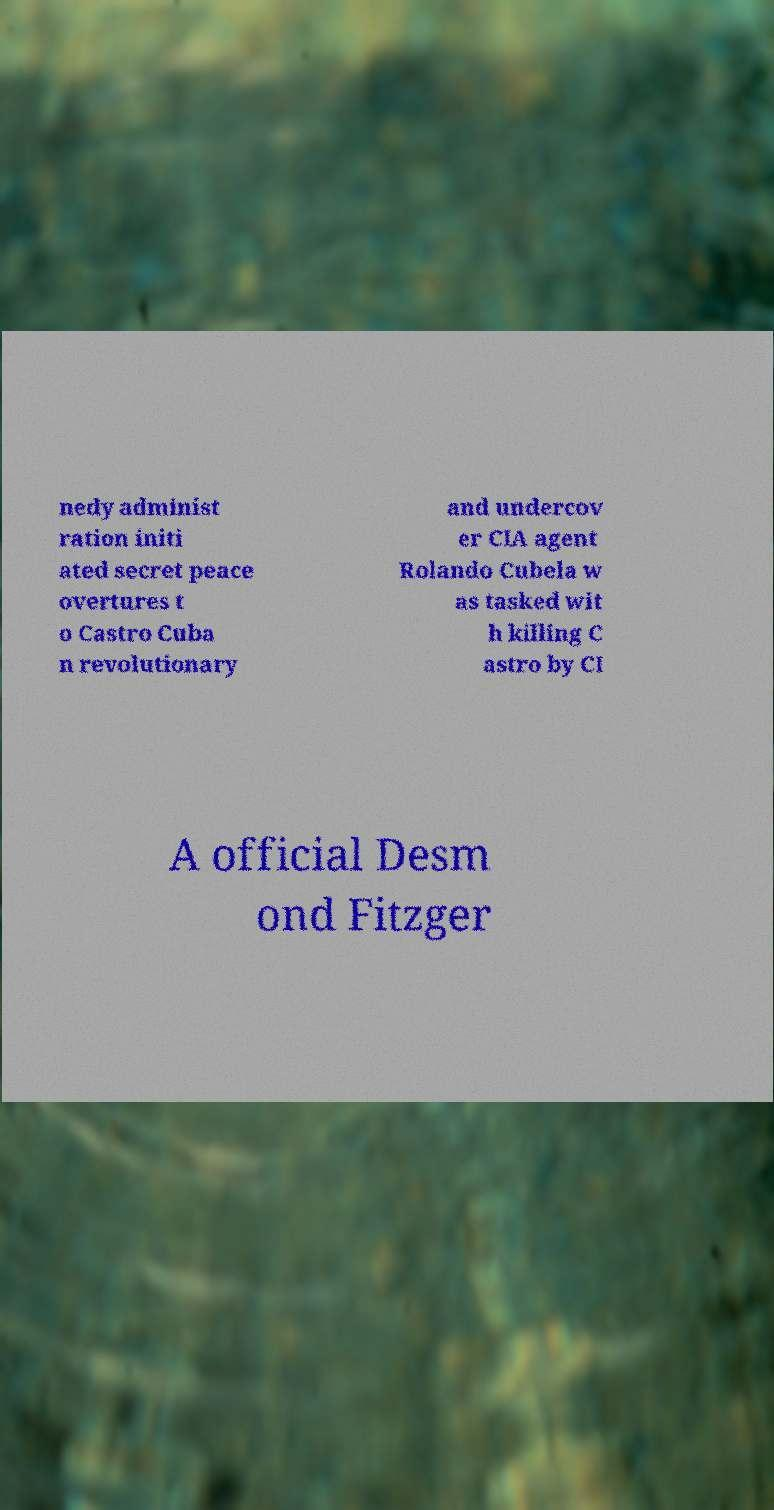Please identify and transcribe the text found in this image. nedy administ ration initi ated secret peace overtures t o Castro Cuba n revolutionary and undercov er CIA agent Rolando Cubela w as tasked wit h killing C astro by CI A official Desm ond Fitzger 